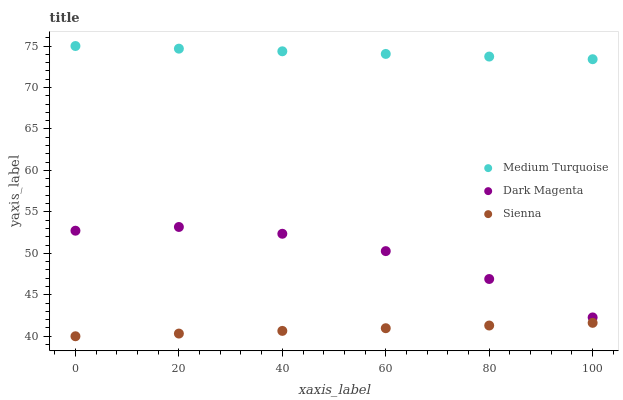Does Sienna have the minimum area under the curve?
Answer yes or no. Yes. Does Medium Turquoise have the maximum area under the curve?
Answer yes or no. Yes. Does Dark Magenta have the minimum area under the curve?
Answer yes or no. No. Does Dark Magenta have the maximum area under the curve?
Answer yes or no. No. Is Sienna the smoothest?
Answer yes or no. Yes. Is Dark Magenta the roughest?
Answer yes or no. Yes. Is Medium Turquoise the smoothest?
Answer yes or no. No. Is Medium Turquoise the roughest?
Answer yes or no. No. Does Sienna have the lowest value?
Answer yes or no. Yes. Does Dark Magenta have the lowest value?
Answer yes or no. No. Does Medium Turquoise have the highest value?
Answer yes or no. Yes. Does Dark Magenta have the highest value?
Answer yes or no. No. Is Sienna less than Medium Turquoise?
Answer yes or no. Yes. Is Medium Turquoise greater than Dark Magenta?
Answer yes or no. Yes. Does Sienna intersect Medium Turquoise?
Answer yes or no. No. 